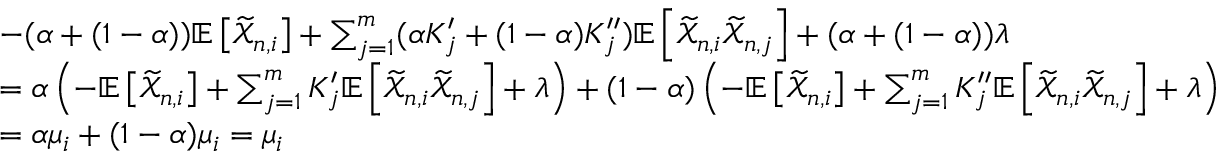Convert formula to latex. <formula><loc_0><loc_0><loc_500><loc_500>\begin{array} { r l } & { - ( \alpha + ( 1 - \alpha ) ) \mathbb { E } \left [ \widetilde { \mathcal { X } } _ { n , i } \right ] + \sum _ { j = 1 } ^ { m } ( \alpha K _ { j } ^ { \prime } + ( 1 - \alpha ) K _ { j } ^ { \prime \prime } ) \mathbb { E } \left [ \widetilde { \mathcal { X } } _ { n , i } \widetilde { \mathcal { X } } _ { n , j } \right ] + ( \alpha + ( 1 - \alpha ) ) \lambda } \\ & { = \alpha \left ( - \mathbb { E } \left [ \widetilde { \mathcal { X } } _ { n , i } \right ] + \sum _ { j = 1 } ^ { m } K _ { j } ^ { \prime } \mathbb { E } \left [ \widetilde { \mathcal { X } } _ { n , i } \widetilde { \mathcal { X } } _ { n , j } \right ] + \lambda \right ) + ( 1 - \alpha ) \left ( - \mathbb { E } \left [ \widetilde { \mathcal { X } } _ { n , i } \right ] + \sum _ { j = 1 } ^ { m } K _ { j } ^ { \prime \prime } \mathbb { E } \left [ \widetilde { \mathcal { X } } _ { n , i } \widetilde { \mathcal { X } } _ { n , j } \right ] + \lambda \right ) } \\ & { = \alpha \mu _ { i } + ( 1 - \alpha ) \mu _ { i } = \mu _ { i } } \end{array}</formula> 